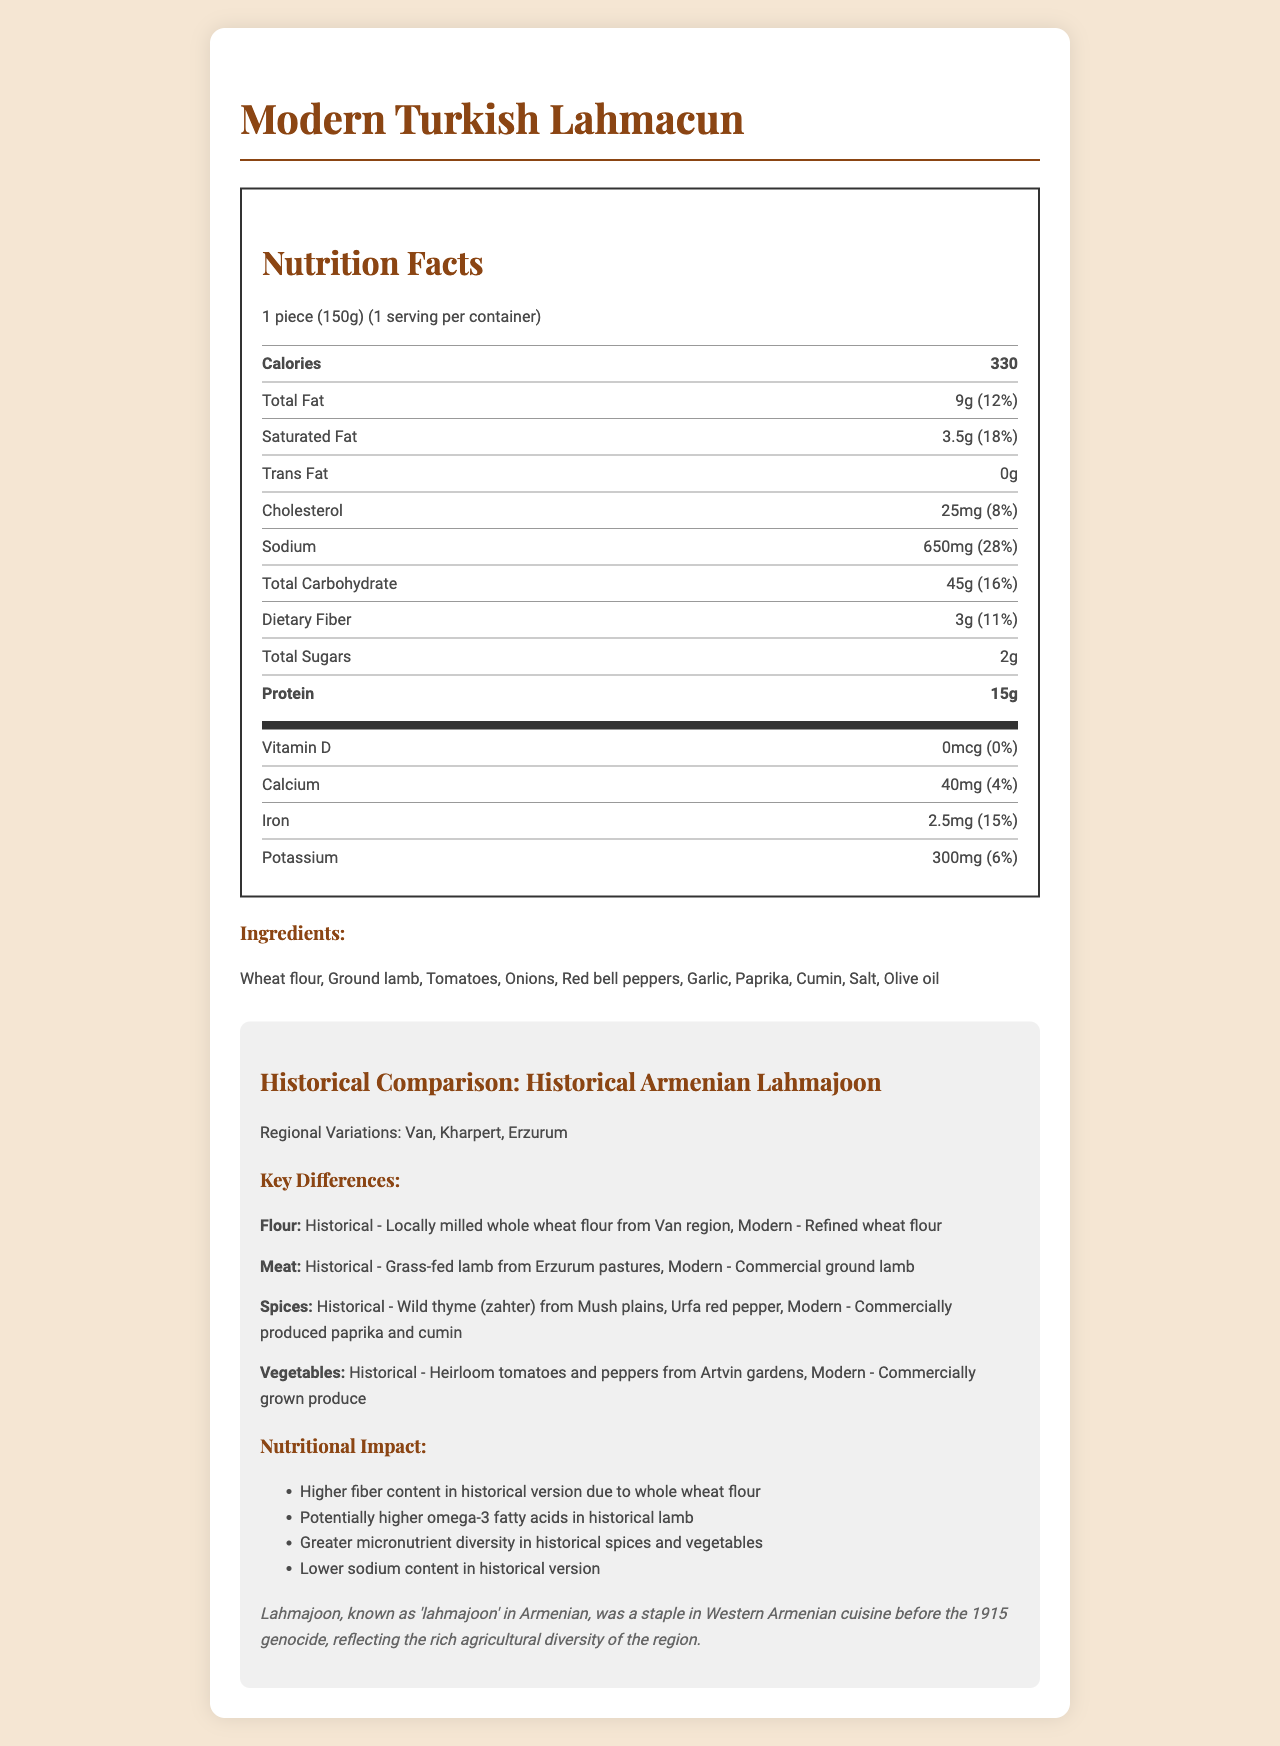what is the serving size for Modern Turkish Lahmacun? The serving size is explicitly mentioned as "1 piece (150g)" in the document.
Answer: 1 piece (150g) how many calories are in one piece of Modern Turkish Lahmacun? The document states that there are 330 calories per serving, which is 1 piece (150g).
Answer: 330 how much dietary fiber does one piece of Modern Turkish Lahmacun contain? The document lists the dietary fiber content as 3g per serving.
Answer: 3 g what are some key differences in meat sources between Modern Turkish Lahmacun and Historical Armenian Lahmajoon? This information is listed in the historical comparison section under key differences for the ingredient "Meat".
Answer: Modern uses commercial ground lamb, whereas historical used grass-fed lamb from Erzurum pastures what is the main type of flour used in Modern Turkish Lahmacun? The document lists the main type of flour in the historical comparison as "Refined wheat flour" for the modern version.
Answer: Refined wheat flour how much sodium does Modern Turkish Lahmacun contain per serving? The document lists the sodium content of Modern Turkish Lahmacun as 650mg.
Answer: 650 mg how does the fiber content in historical lahmajoon compare to the modern version? The document mentions higher fiber content in the historical version due to the use of whole wheat flour.
Answer: Higher in historical version which regional variations of Historical Armenian Lahmajoon are mentioned in the document? A. Van B. Kharpert C. Erzurum D. All of the above The document lists regional variations from Van, Kharpert, and Erzurum.
Answer: D. All of the above which ingredient in the Modern Turkish Lahmacun contributes the most to daily protein value? A. Wheat flour B. Ground lamb C. Tomatoes The document lists protein amount as 15g and 30% daily value, largely attributed to the presence of ground lamb.
Answer: B. Ground lamb are heirloom tomatoes used in Modern Turkish Lahmacun? The document mentions that commercially grown produce is used in the modern version, indicating heirloom tomatoes are not used.
Answer: No does the Modern Turkish Lahmacun contain trans fat? The document shows that the amount of trans fat is 0g.
Answer: No write a summary of the main differences between Modern Turkish Lahmacun and Historical Armenian Lahmajoon. This summary encapsulates the document's main ideas regarding the key differences in ingredients, nutritional impacts, and the cultural significance of the Historical Armenian Lahmajoon.
Answer: Modern Turkish Lahmacun uses commercially produced ingredients with refined wheat flour, commercial ground lamb, and standard paprika and cumin, whereas Historical Armenian Lahmajoon utilized local and heirloom ingredients like whole wheat flour, grass-fed lamb, wild thyme, and Urfa red pepper. The historical version also had better nutritional attributes such as higher fiber content and potentially more omega-3 fatty acids. The cultural significance of Lahmajoon roots back to Western Armenian cuisine before the 1915 genocide, reflecting the rich agricultural diversity of the region. does the document provide specific numbers for omega-3 fatty acids in Historical Armenian Lahmajoon? The document mentions "potentially higher omega-3 fatty acids" in the historical version but does not provide specific numbers or measurements.
Answer: Not enough information 